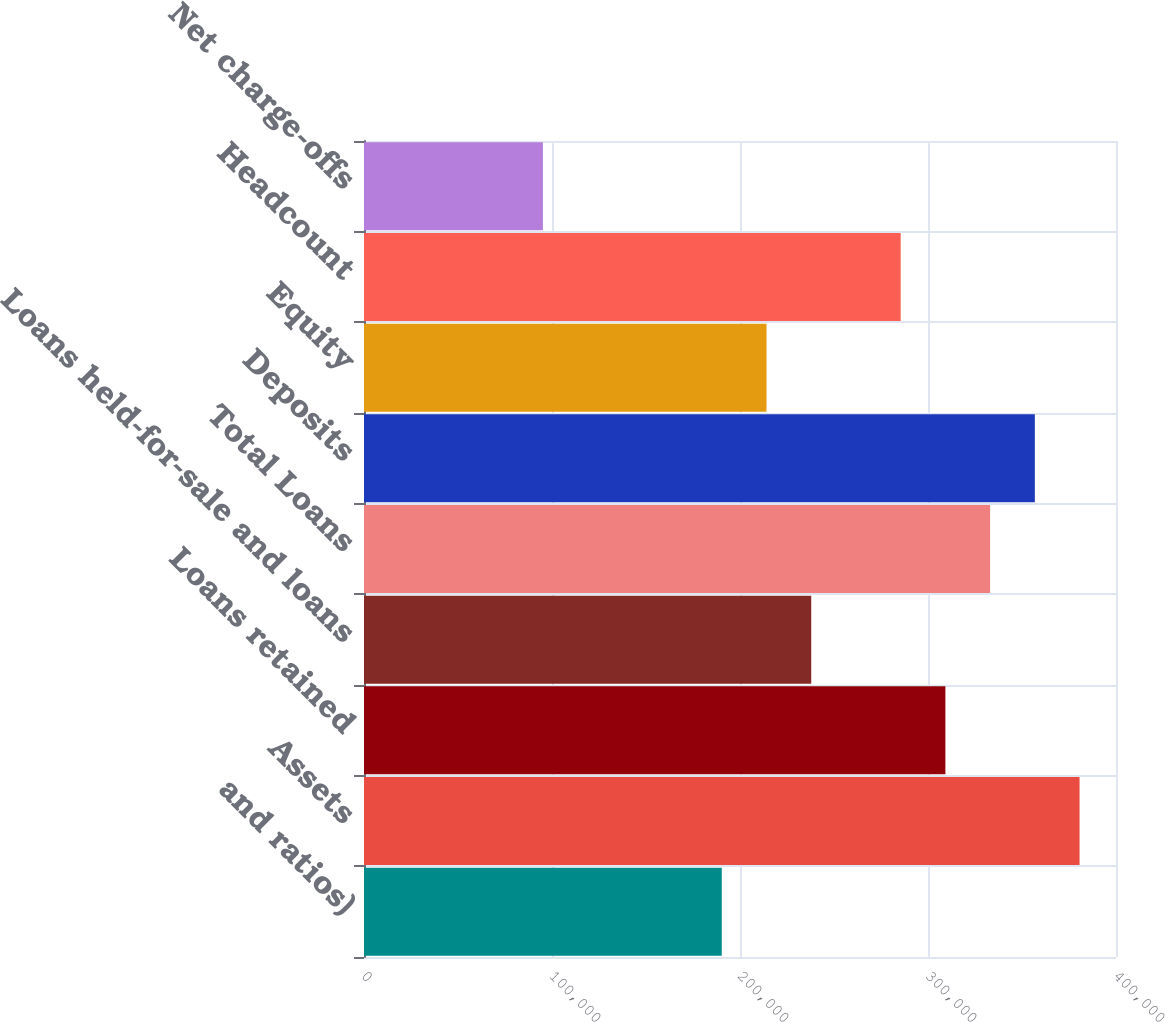Convert chart to OTSL. <chart><loc_0><loc_0><loc_500><loc_500><bar_chart><fcel>and ratios)<fcel>Assets<fcel>Loans retained<fcel>Loans held-for-sale and loans<fcel>Total Loans<fcel>Deposits<fcel>Equity<fcel>Headcount<fcel>Net charge-offs<nl><fcel>190310<fcel>380619<fcel>309253<fcel>237887<fcel>333042<fcel>356830<fcel>214098<fcel>285464<fcel>95155<nl></chart> 